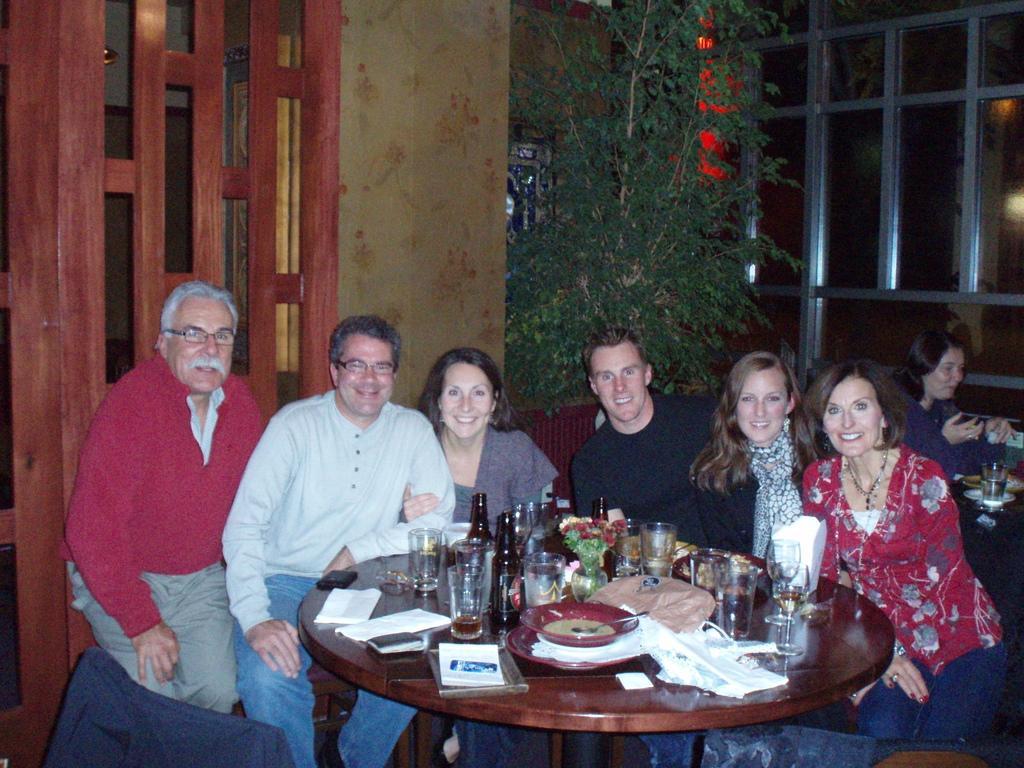Could you give a brief overview of what you see in this image? In this image, In the middle there is a brown color table and on that table there are some glasses and there is plate and there are some papers in white color, There are some people sitting on the chairs around the table, In the background there is a green color plant and a brown color wooden block and there is a yellow color curtain. 